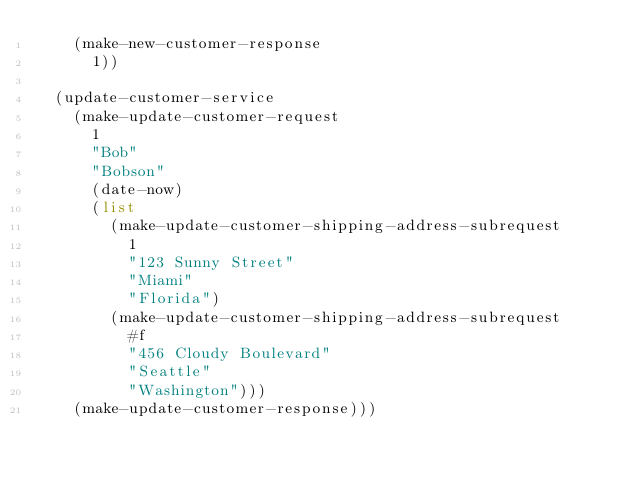Convert code to text. <code><loc_0><loc_0><loc_500><loc_500><_Scheme_>    (make-new-customer-response
      1))

  (update-customer-service
    (make-update-customer-request
      1
      "Bob"
      "Bobson"
      (date-now)
      (list
        (make-update-customer-shipping-address-subrequest
          1
          "123 Sunny Street"
          "Miami"
          "Florida")
        (make-update-customer-shipping-address-subrequest
          #f
          "456 Cloudy Boulevard"
          "Seattle"
          "Washington")))
    (make-update-customer-response)))
</code> 